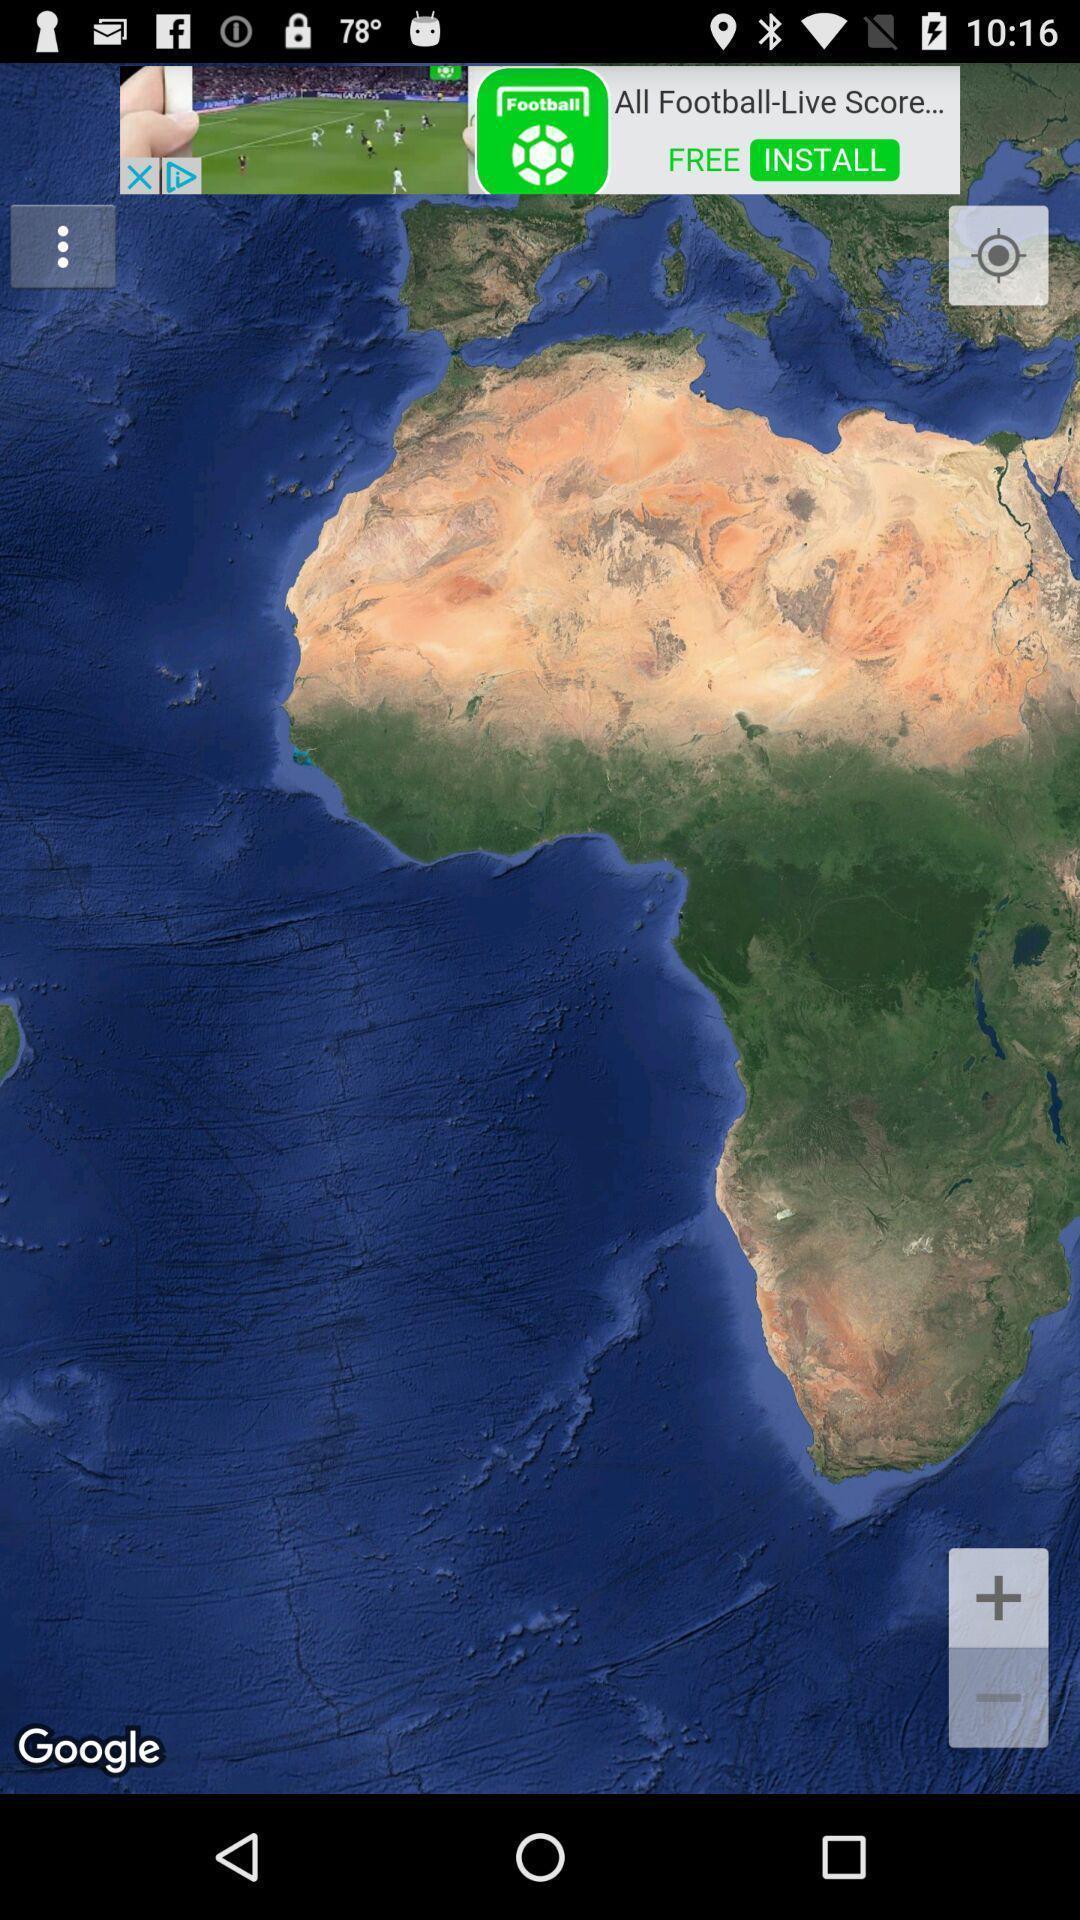Provide a textual representation of this image. Screen displaying the map with gps. 